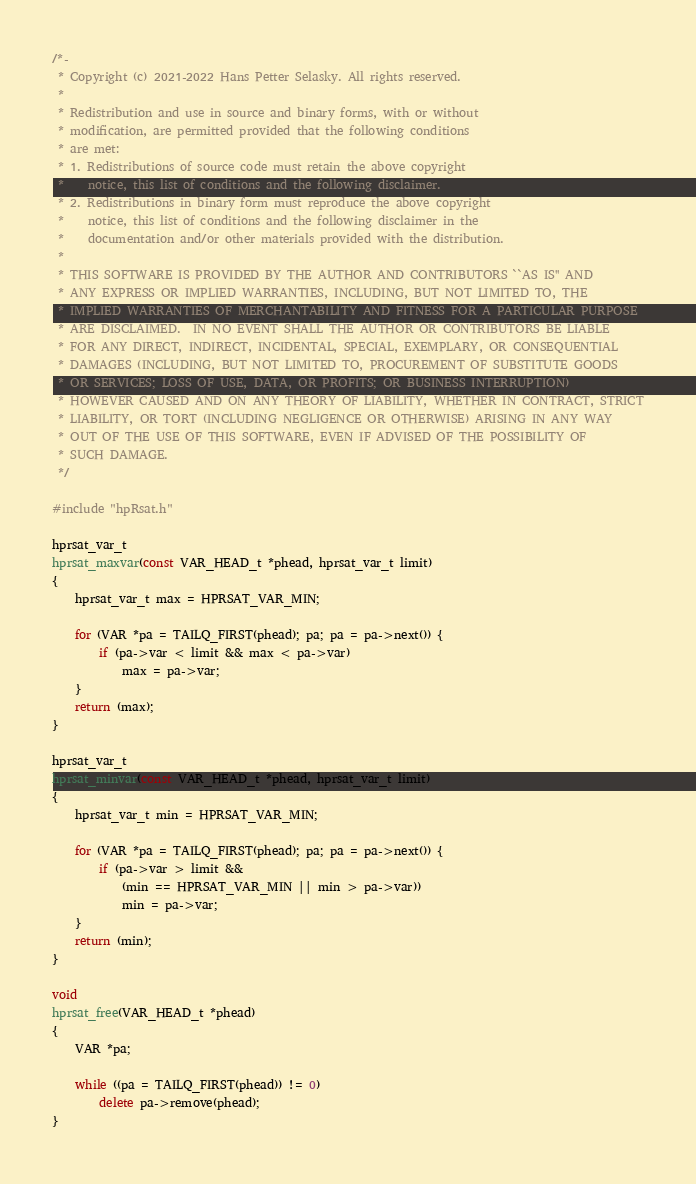<code> <loc_0><loc_0><loc_500><loc_500><_C++_>/*-
 * Copyright (c) 2021-2022 Hans Petter Selasky. All rights reserved.
 *
 * Redistribution and use in source and binary forms, with or without
 * modification, are permitted provided that the following conditions
 * are met:
 * 1. Redistributions of source code must retain the above copyright
 *    notice, this list of conditions and the following disclaimer.
 * 2. Redistributions in binary form must reproduce the above copyright
 *    notice, this list of conditions and the following disclaimer in the
 *    documentation and/or other materials provided with the distribution.
 *
 * THIS SOFTWARE IS PROVIDED BY THE AUTHOR AND CONTRIBUTORS ``AS IS'' AND
 * ANY EXPRESS OR IMPLIED WARRANTIES, INCLUDING, BUT NOT LIMITED TO, THE
 * IMPLIED WARRANTIES OF MERCHANTABILITY AND FITNESS FOR A PARTICULAR PURPOSE
 * ARE DISCLAIMED.  IN NO EVENT SHALL THE AUTHOR OR CONTRIBUTORS BE LIABLE
 * FOR ANY DIRECT, INDIRECT, INCIDENTAL, SPECIAL, EXEMPLARY, OR CONSEQUENTIAL
 * DAMAGES (INCLUDING, BUT NOT LIMITED TO, PROCUREMENT OF SUBSTITUTE GOODS
 * OR SERVICES; LOSS OF USE, DATA, OR PROFITS; OR BUSINESS INTERRUPTION)
 * HOWEVER CAUSED AND ON ANY THEORY OF LIABILITY, WHETHER IN CONTRACT, STRICT
 * LIABILITY, OR TORT (INCLUDING NEGLIGENCE OR OTHERWISE) ARISING IN ANY WAY
 * OUT OF THE USE OF THIS SOFTWARE, EVEN IF ADVISED OF THE POSSIBILITY OF
 * SUCH DAMAGE.
 */

#include "hpRsat.h"

hprsat_var_t
hprsat_maxvar(const VAR_HEAD_t *phead, hprsat_var_t limit)
{
	hprsat_var_t max = HPRSAT_VAR_MIN;

	for (VAR *pa = TAILQ_FIRST(phead); pa; pa = pa->next()) {
		if (pa->var < limit && max < pa->var)
			max = pa->var;
	}
	return (max);
}

hprsat_var_t
hprsat_minvar(const VAR_HEAD_t *phead, hprsat_var_t limit)
{
	hprsat_var_t min = HPRSAT_VAR_MIN;

	for (VAR *pa = TAILQ_FIRST(phead); pa; pa = pa->next()) {
		if (pa->var > limit &&
		    (min == HPRSAT_VAR_MIN || min > pa->var))
			min = pa->var;
	}
	return (min);
}

void
hprsat_free(VAR_HEAD_t *phead)
{
	VAR *pa;

	while ((pa = TAILQ_FIRST(phead)) != 0)
		delete pa->remove(phead);
}
</code> 